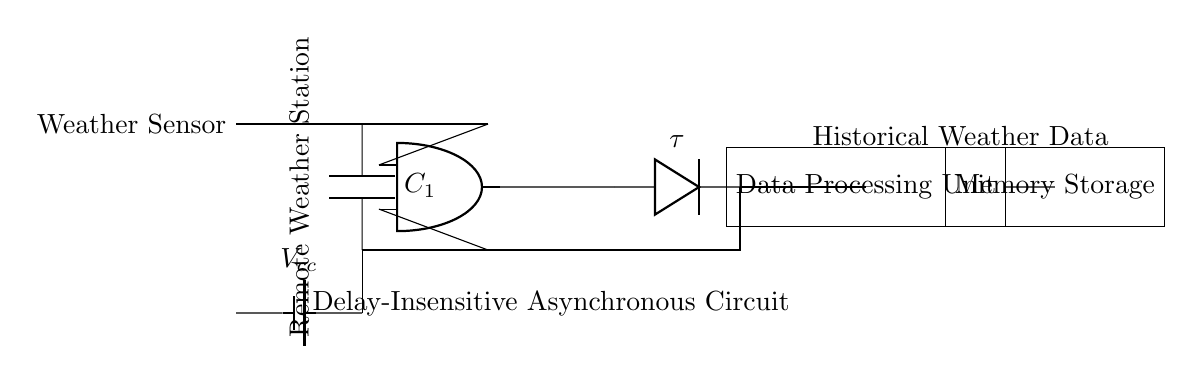What is the main component that processes data? The main component that processes data is labeled as the "Data Processing Unit" in the circuit diagram, which is represented as a rectangle.
Answer: Data Processing Unit What is the purpose of the capacitor in this circuit? The capacitor, labeled as C1, typically helps in smoothing or storing energy within the circuit, allowing for stable operation by filtering voltage fluctuations from the weather sensor.
Answer: Smoothing energy What is the role of the Muller C-Element? The Muller C-Element is an asynchronous component serving a fundamental role in ensuring that the output reflects the consensus of its inputs, which is particularly useful in delay-insensitive circuits.
Answer: Synchronizing inputs What is the significance of the delay element labeled as tau? The delay element labeled as tau introduces a specific time delay into the circuit, which is crucial for ensuring that asynchronous signals are received and processed correctly, thus maintaining the overall timing coordination.
Answer: Introducing time delay How is the feedback loop structured in this circuit? The feedback loop is structured by connecting the output from the delay element back to the input of the capacitor, creating a path that can allow for continuous operation and data cycling within the circuit.
Answer: Connecting outputs to inputs What is the supply voltage labeled in this circuit? The supply voltage is labeled as Vcc, which refers to the positive voltage supply used to power the components of the circuit.
Answer: Vcc What is being stored in the memory storage unit? The memory storage unit is designed to store historical weather data, as indicated in the labeling, which is essential for tracking weather patterns over time in remote areas.
Answer: Historical weather data 